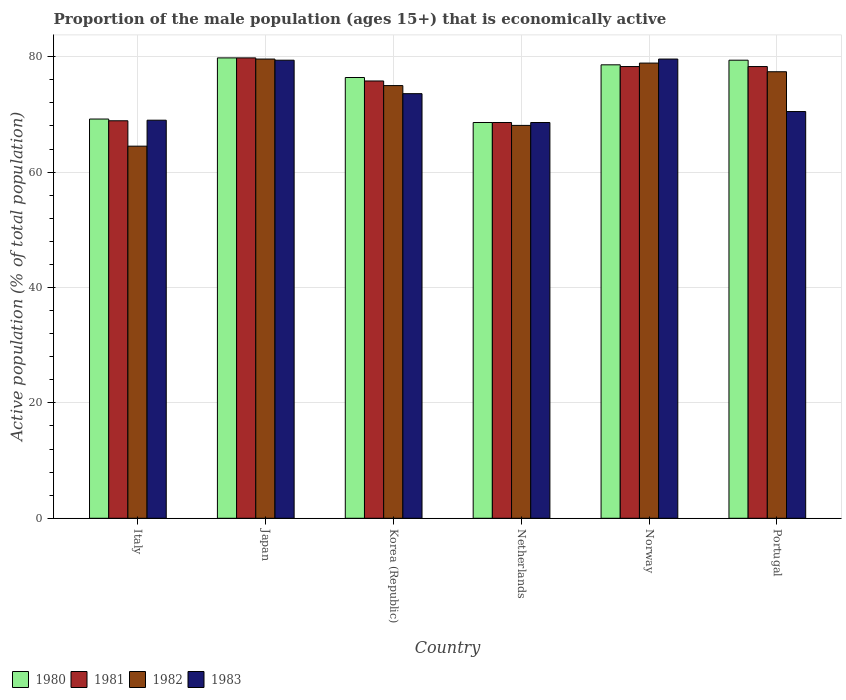How many different coloured bars are there?
Provide a succinct answer. 4. Are the number of bars per tick equal to the number of legend labels?
Keep it short and to the point. Yes. How many bars are there on the 4th tick from the right?
Offer a terse response. 4. What is the proportion of the male population that is economically active in 1982 in Korea (Republic)?
Give a very brief answer. 75. Across all countries, what is the maximum proportion of the male population that is economically active in 1982?
Make the answer very short. 79.6. Across all countries, what is the minimum proportion of the male population that is economically active in 1983?
Your answer should be compact. 68.6. In which country was the proportion of the male population that is economically active in 1981 minimum?
Ensure brevity in your answer.  Netherlands. What is the total proportion of the male population that is economically active in 1980 in the graph?
Your answer should be compact. 452. What is the difference between the proportion of the male population that is economically active in 1982 in Japan and that in Korea (Republic)?
Your answer should be compact. 4.6. What is the average proportion of the male population that is economically active in 1982 per country?
Give a very brief answer. 73.92. What is the ratio of the proportion of the male population that is economically active in 1980 in Japan to that in Norway?
Keep it short and to the point. 1.02. Is the proportion of the male population that is economically active in 1981 in Japan less than that in Korea (Republic)?
Your answer should be very brief. No. Is the difference between the proportion of the male population that is economically active in 1982 in Italy and Netherlands greater than the difference between the proportion of the male population that is economically active in 1980 in Italy and Netherlands?
Your answer should be very brief. No. What is the difference between the highest and the second highest proportion of the male population that is economically active in 1983?
Provide a succinct answer. -5.8. What is the difference between the highest and the lowest proportion of the male population that is economically active in 1981?
Offer a very short reply. 11.2. In how many countries, is the proportion of the male population that is economically active in 1983 greater than the average proportion of the male population that is economically active in 1983 taken over all countries?
Your answer should be very brief. 3. Is it the case that in every country, the sum of the proportion of the male population that is economically active in 1981 and proportion of the male population that is economically active in 1983 is greater than the sum of proportion of the male population that is economically active in 1982 and proportion of the male population that is economically active in 1980?
Provide a short and direct response. No. What does the 3rd bar from the left in Japan represents?
Ensure brevity in your answer.  1982. Is it the case that in every country, the sum of the proportion of the male population that is economically active in 1983 and proportion of the male population that is economically active in 1980 is greater than the proportion of the male population that is economically active in 1982?
Offer a very short reply. Yes. How many bars are there?
Offer a very short reply. 24. How many countries are there in the graph?
Provide a short and direct response. 6. What is the difference between two consecutive major ticks on the Y-axis?
Provide a succinct answer. 20. Where does the legend appear in the graph?
Provide a succinct answer. Bottom left. What is the title of the graph?
Offer a terse response. Proportion of the male population (ages 15+) that is economically active. What is the label or title of the Y-axis?
Provide a succinct answer. Active population (% of total population). What is the Active population (% of total population) of 1980 in Italy?
Give a very brief answer. 69.2. What is the Active population (% of total population) of 1981 in Italy?
Give a very brief answer. 68.9. What is the Active population (% of total population) of 1982 in Italy?
Provide a short and direct response. 64.5. What is the Active population (% of total population) of 1980 in Japan?
Make the answer very short. 79.8. What is the Active population (% of total population) in 1981 in Japan?
Offer a very short reply. 79.8. What is the Active population (% of total population) of 1982 in Japan?
Offer a very short reply. 79.6. What is the Active population (% of total population) in 1983 in Japan?
Offer a very short reply. 79.4. What is the Active population (% of total population) in 1980 in Korea (Republic)?
Give a very brief answer. 76.4. What is the Active population (% of total population) of 1981 in Korea (Republic)?
Offer a terse response. 75.8. What is the Active population (% of total population) in 1982 in Korea (Republic)?
Offer a very short reply. 75. What is the Active population (% of total population) in 1983 in Korea (Republic)?
Offer a terse response. 73.6. What is the Active population (% of total population) in 1980 in Netherlands?
Offer a very short reply. 68.6. What is the Active population (% of total population) of 1981 in Netherlands?
Your answer should be very brief. 68.6. What is the Active population (% of total population) in 1982 in Netherlands?
Provide a short and direct response. 68.1. What is the Active population (% of total population) in 1983 in Netherlands?
Your answer should be compact. 68.6. What is the Active population (% of total population) in 1980 in Norway?
Your answer should be very brief. 78.6. What is the Active population (% of total population) in 1981 in Norway?
Offer a very short reply. 78.3. What is the Active population (% of total population) of 1982 in Norway?
Your answer should be compact. 78.9. What is the Active population (% of total population) in 1983 in Norway?
Offer a very short reply. 79.6. What is the Active population (% of total population) in 1980 in Portugal?
Offer a terse response. 79.4. What is the Active population (% of total population) of 1981 in Portugal?
Provide a short and direct response. 78.3. What is the Active population (% of total population) of 1982 in Portugal?
Offer a very short reply. 77.4. What is the Active population (% of total population) of 1983 in Portugal?
Keep it short and to the point. 70.5. Across all countries, what is the maximum Active population (% of total population) in 1980?
Ensure brevity in your answer.  79.8. Across all countries, what is the maximum Active population (% of total population) of 1981?
Make the answer very short. 79.8. Across all countries, what is the maximum Active population (% of total population) of 1982?
Offer a terse response. 79.6. Across all countries, what is the maximum Active population (% of total population) of 1983?
Keep it short and to the point. 79.6. Across all countries, what is the minimum Active population (% of total population) of 1980?
Give a very brief answer. 68.6. Across all countries, what is the minimum Active population (% of total population) in 1981?
Your answer should be very brief. 68.6. Across all countries, what is the minimum Active population (% of total population) in 1982?
Offer a terse response. 64.5. Across all countries, what is the minimum Active population (% of total population) of 1983?
Your answer should be compact. 68.6. What is the total Active population (% of total population) in 1980 in the graph?
Your answer should be compact. 452. What is the total Active population (% of total population) of 1981 in the graph?
Your answer should be very brief. 449.7. What is the total Active population (% of total population) in 1982 in the graph?
Provide a succinct answer. 443.5. What is the total Active population (% of total population) of 1983 in the graph?
Give a very brief answer. 440.7. What is the difference between the Active population (% of total population) in 1980 in Italy and that in Japan?
Give a very brief answer. -10.6. What is the difference between the Active population (% of total population) in 1982 in Italy and that in Japan?
Offer a very short reply. -15.1. What is the difference between the Active population (% of total population) of 1980 in Italy and that in Korea (Republic)?
Your response must be concise. -7.2. What is the difference between the Active population (% of total population) in 1982 in Italy and that in Korea (Republic)?
Provide a succinct answer. -10.5. What is the difference between the Active population (% of total population) of 1982 in Italy and that in Netherlands?
Your answer should be compact. -3.6. What is the difference between the Active population (% of total population) of 1983 in Italy and that in Netherlands?
Offer a very short reply. 0.4. What is the difference between the Active population (% of total population) of 1981 in Italy and that in Norway?
Offer a very short reply. -9.4. What is the difference between the Active population (% of total population) in 1982 in Italy and that in Norway?
Keep it short and to the point. -14.4. What is the difference between the Active population (% of total population) in 1980 in Italy and that in Portugal?
Offer a very short reply. -10.2. What is the difference between the Active population (% of total population) in 1981 in Italy and that in Portugal?
Offer a very short reply. -9.4. What is the difference between the Active population (% of total population) of 1980 in Japan and that in Korea (Republic)?
Ensure brevity in your answer.  3.4. What is the difference between the Active population (% of total population) of 1983 in Japan and that in Korea (Republic)?
Your answer should be compact. 5.8. What is the difference between the Active population (% of total population) of 1982 in Japan and that in Netherlands?
Ensure brevity in your answer.  11.5. What is the difference between the Active population (% of total population) in 1980 in Japan and that in Norway?
Give a very brief answer. 1.2. What is the difference between the Active population (% of total population) in 1982 in Japan and that in Norway?
Your answer should be compact. 0.7. What is the difference between the Active population (% of total population) in 1981 in Japan and that in Portugal?
Offer a terse response. 1.5. What is the difference between the Active population (% of total population) of 1982 in Japan and that in Portugal?
Provide a short and direct response. 2.2. What is the difference between the Active population (% of total population) in 1980 in Korea (Republic) and that in Netherlands?
Offer a terse response. 7.8. What is the difference between the Active population (% of total population) in 1982 in Korea (Republic) and that in Netherlands?
Provide a short and direct response. 6.9. What is the difference between the Active population (% of total population) of 1983 in Korea (Republic) and that in Netherlands?
Your response must be concise. 5. What is the difference between the Active population (% of total population) of 1982 in Korea (Republic) and that in Norway?
Offer a very short reply. -3.9. What is the difference between the Active population (% of total population) of 1983 in Korea (Republic) and that in Norway?
Offer a very short reply. -6. What is the difference between the Active population (% of total population) in 1980 in Korea (Republic) and that in Portugal?
Your answer should be very brief. -3. What is the difference between the Active population (% of total population) of 1983 in Korea (Republic) and that in Portugal?
Offer a terse response. 3.1. What is the difference between the Active population (% of total population) of 1980 in Netherlands and that in Norway?
Offer a very short reply. -10. What is the difference between the Active population (% of total population) of 1981 in Netherlands and that in Norway?
Ensure brevity in your answer.  -9.7. What is the difference between the Active population (% of total population) in 1982 in Netherlands and that in Norway?
Give a very brief answer. -10.8. What is the difference between the Active population (% of total population) of 1983 in Netherlands and that in Norway?
Ensure brevity in your answer.  -11. What is the difference between the Active population (% of total population) of 1982 in Netherlands and that in Portugal?
Provide a succinct answer. -9.3. What is the difference between the Active population (% of total population) of 1983 in Netherlands and that in Portugal?
Make the answer very short. -1.9. What is the difference between the Active population (% of total population) in 1983 in Norway and that in Portugal?
Provide a short and direct response. 9.1. What is the difference between the Active population (% of total population) of 1980 in Italy and the Active population (% of total population) of 1981 in Japan?
Offer a terse response. -10.6. What is the difference between the Active population (% of total population) in 1982 in Italy and the Active population (% of total population) in 1983 in Japan?
Your answer should be very brief. -14.9. What is the difference between the Active population (% of total population) in 1980 in Italy and the Active population (% of total population) in 1981 in Netherlands?
Your answer should be compact. 0.6. What is the difference between the Active population (% of total population) of 1981 in Italy and the Active population (% of total population) of 1983 in Netherlands?
Keep it short and to the point. 0.3. What is the difference between the Active population (% of total population) in 1980 in Italy and the Active population (% of total population) in 1981 in Norway?
Give a very brief answer. -9.1. What is the difference between the Active population (% of total population) in 1980 in Italy and the Active population (% of total population) in 1982 in Norway?
Ensure brevity in your answer.  -9.7. What is the difference between the Active population (% of total population) of 1981 in Italy and the Active population (% of total population) of 1982 in Norway?
Your answer should be compact. -10. What is the difference between the Active population (% of total population) in 1981 in Italy and the Active population (% of total population) in 1983 in Norway?
Your answer should be very brief. -10.7. What is the difference between the Active population (% of total population) in 1982 in Italy and the Active population (% of total population) in 1983 in Norway?
Provide a succinct answer. -15.1. What is the difference between the Active population (% of total population) of 1980 in Italy and the Active population (% of total population) of 1981 in Portugal?
Provide a succinct answer. -9.1. What is the difference between the Active population (% of total population) of 1981 in Italy and the Active population (% of total population) of 1982 in Portugal?
Offer a very short reply. -8.5. What is the difference between the Active population (% of total population) of 1981 in Italy and the Active population (% of total population) of 1983 in Portugal?
Keep it short and to the point. -1.6. What is the difference between the Active population (% of total population) in 1982 in Italy and the Active population (% of total population) in 1983 in Portugal?
Keep it short and to the point. -6. What is the difference between the Active population (% of total population) of 1980 in Japan and the Active population (% of total population) of 1981 in Korea (Republic)?
Offer a very short reply. 4. What is the difference between the Active population (% of total population) in 1981 in Japan and the Active population (% of total population) in 1982 in Korea (Republic)?
Offer a very short reply. 4.8. What is the difference between the Active population (% of total population) in 1981 in Japan and the Active population (% of total population) in 1983 in Korea (Republic)?
Ensure brevity in your answer.  6.2. What is the difference between the Active population (% of total population) of 1982 in Japan and the Active population (% of total population) of 1983 in Korea (Republic)?
Provide a succinct answer. 6. What is the difference between the Active population (% of total population) of 1980 in Japan and the Active population (% of total population) of 1983 in Netherlands?
Your response must be concise. 11.2. What is the difference between the Active population (% of total population) in 1981 in Japan and the Active population (% of total population) in 1983 in Netherlands?
Your answer should be compact. 11.2. What is the difference between the Active population (% of total population) of 1980 in Japan and the Active population (% of total population) of 1981 in Norway?
Keep it short and to the point. 1.5. What is the difference between the Active population (% of total population) of 1980 in Japan and the Active population (% of total population) of 1982 in Norway?
Your response must be concise. 0.9. What is the difference between the Active population (% of total population) of 1981 in Japan and the Active population (% of total population) of 1982 in Norway?
Your response must be concise. 0.9. What is the difference between the Active population (% of total population) of 1981 in Japan and the Active population (% of total population) of 1983 in Norway?
Offer a very short reply. 0.2. What is the difference between the Active population (% of total population) in 1982 in Japan and the Active population (% of total population) in 1983 in Norway?
Make the answer very short. 0. What is the difference between the Active population (% of total population) of 1980 in Japan and the Active population (% of total population) of 1982 in Portugal?
Give a very brief answer. 2.4. What is the difference between the Active population (% of total population) of 1980 in Japan and the Active population (% of total population) of 1983 in Portugal?
Keep it short and to the point. 9.3. What is the difference between the Active population (% of total population) in 1981 in Japan and the Active population (% of total population) in 1982 in Portugal?
Ensure brevity in your answer.  2.4. What is the difference between the Active population (% of total population) of 1982 in Japan and the Active population (% of total population) of 1983 in Portugal?
Ensure brevity in your answer.  9.1. What is the difference between the Active population (% of total population) in 1980 in Korea (Republic) and the Active population (% of total population) in 1981 in Netherlands?
Make the answer very short. 7.8. What is the difference between the Active population (% of total population) in 1980 in Korea (Republic) and the Active population (% of total population) in 1982 in Netherlands?
Make the answer very short. 8.3. What is the difference between the Active population (% of total population) of 1981 in Korea (Republic) and the Active population (% of total population) of 1983 in Netherlands?
Make the answer very short. 7.2. What is the difference between the Active population (% of total population) in 1982 in Korea (Republic) and the Active population (% of total population) in 1983 in Netherlands?
Keep it short and to the point. 6.4. What is the difference between the Active population (% of total population) in 1980 in Korea (Republic) and the Active population (% of total population) in 1981 in Norway?
Ensure brevity in your answer.  -1.9. What is the difference between the Active population (% of total population) of 1980 in Korea (Republic) and the Active population (% of total population) of 1982 in Norway?
Ensure brevity in your answer.  -2.5. What is the difference between the Active population (% of total population) of 1980 in Korea (Republic) and the Active population (% of total population) of 1983 in Norway?
Offer a very short reply. -3.2. What is the difference between the Active population (% of total population) of 1981 in Korea (Republic) and the Active population (% of total population) of 1983 in Norway?
Ensure brevity in your answer.  -3.8. What is the difference between the Active population (% of total population) of 1980 in Netherlands and the Active population (% of total population) of 1983 in Norway?
Provide a short and direct response. -11. What is the difference between the Active population (% of total population) of 1981 in Netherlands and the Active population (% of total population) of 1983 in Norway?
Your answer should be compact. -11. What is the difference between the Active population (% of total population) of 1981 in Netherlands and the Active population (% of total population) of 1982 in Portugal?
Your answer should be compact. -8.8. What is the difference between the Active population (% of total population) in 1981 in Netherlands and the Active population (% of total population) in 1983 in Portugal?
Provide a succinct answer. -1.9. What is the difference between the Active population (% of total population) in 1982 in Netherlands and the Active population (% of total population) in 1983 in Portugal?
Keep it short and to the point. -2.4. What is the difference between the Active population (% of total population) of 1980 in Norway and the Active population (% of total population) of 1983 in Portugal?
Your response must be concise. 8.1. What is the average Active population (% of total population) in 1980 per country?
Keep it short and to the point. 75.33. What is the average Active population (% of total population) of 1981 per country?
Keep it short and to the point. 74.95. What is the average Active population (% of total population) of 1982 per country?
Make the answer very short. 73.92. What is the average Active population (% of total population) in 1983 per country?
Your response must be concise. 73.45. What is the difference between the Active population (% of total population) in 1981 and Active population (% of total population) in 1983 in Italy?
Your answer should be very brief. -0.1. What is the difference between the Active population (% of total population) of 1982 and Active population (% of total population) of 1983 in Italy?
Ensure brevity in your answer.  -4.5. What is the difference between the Active population (% of total population) of 1980 and Active population (% of total population) of 1982 in Japan?
Ensure brevity in your answer.  0.2. What is the difference between the Active population (% of total population) of 1980 and Active population (% of total population) of 1983 in Japan?
Keep it short and to the point. 0.4. What is the difference between the Active population (% of total population) of 1981 and Active population (% of total population) of 1983 in Japan?
Keep it short and to the point. 0.4. What is the difference between the Active population (% of total population) in 1980 and Active population (% of total population) in 1981 in Korea (Republic)?
Offer a very short reply. 0.6. What is the difference between the Active population (% of total population) in 1980 and Active population (% of total population) in 1982 in Korea (Republic)?
Your answer should be compact. 1.4. What is the difference between the Active population (% of total population) of 1981 and Active population (% of total population) of 1982 in Korea (Republic)?
Your answer should be very brief. 0.8. What is the difference between the Active population (% of total population) in 1981 and Active population (% of total population) in 1983 in Korea (Republic)?
Keep it short and to the point. 2.2. What is the difference between the Active population (% of total population) in 1980 and Active population (% of total population) in 1981 in Netherlands?
Make the answer very short. 0. What is the difference between the Active population (% of total population) in 1980 and Active population (% of total population) in 1983 in Netherlands?
Provide a short and direct response. 0. What is the difference between the Active population (% of total population) in 1981 and Active population (% of total population) in 1982 in Netherlands?
Provide a short and direct response. 0.5. What is the difference between the Active population (% of total population) in 1981 and Active population (% of total population) in 1983 in Netherlands?
Your answer should be compact. 0. What is the difference between the Active population (% of total population) in 1980 and Active population (% of total population) in 1982 in Norway?
Offer a very short reply. -0.3. What is the difference between the Active population (% of total population) of 1982 and Active population (% of total population) of 1983 in Norway?
Make the answer very short. -0.7. What is the difference between the Active population (% of total population) of 1980 and Active population (% of total population) of 1981 in Portugal?
Give a very brief answer. 1.1. What is the difference between the Active population (% of total population) of 1980 and Active population (% of total population) of 1983 in Portugal?
Make the answer very short. 8.9. What is the difference between the Active population (% of total population) in 1981 and Active population (% of total population) in 1982 in Portugal?
Provide a short and direct response. 0.9. What is the difference between the Active population (% of total population) of 1981 and Active population (% of total population) of 1983 in Portugal?
Your response must be concise. 7.8. What is the ratio of the Active population (% of total population) in 1980 in Italy to that in Japan?
Give a very brief answer. 0.87. What is the ratio of the Active population (% of total population) in 1981 in Italy to that in Japan?
Your answer should be compact. 0.86. What is the ratio of the Active population (% of total population) in 1982 in Italy to that in Japan?
Your response must be concise. 0.81. What is the ratio of the Active population (% of total population) in 1983 in Italy to that in Japan?
Provide a succinct answer. 0.87. What is the ratio of the Active population (% of total population) of 1980 in Italy to that in Korea (Republic)?
Give a very brief answer. 0.91. What is the ratio of the Active population (% of total population) of 1981 in Italy to that in Korea (Republic)?
Make the answer very short. 0.91. What is the ratio of the Active population (% of total population) in 1982 in Italy to that in Korea (Republic)?
Your response must be concise. 0.86. What is the ratio of the Active population (% of total population) in 1983 in Italy to that in Korea (Republic)?
Make the answer very short. 0.94. What is the ratio of the Active population (% of total population) of 1980 in Italy to that in Netherlands?
Keep it short and to the point. 1.01. What is the ratio of the Active population (% of total population) of 1981 in Italy to that in Netherlands?
Offer a very short reply. 1. What is the ratio of the Active population (% of total population) of 1982 in Italy to that in Netherlands?
Provide a succinct answer. 0.95. What is the ratio of the Active population (% of total population) in 1983 in Italy to that in Netherlands?
Make the answer very short. 1.01. What is the ratio of the Active population (% of total population) of 1980 in Italy to that in Norway?
Make the answer very short. 0.88. What is the ratio of the Active population (% of total population) of 1981 in Italy to that in Norway?
Your answer should be compact. 0.88. What is the ratio of the Active population (% of total population) in 1982 in Italy to that in Norway?
Your answer should be very brief. 0.82. What is the ratio of the Active population (% of total population) of 1983 in Italy to that in Norway?
Your response must be concise. 0.87. What is the ratio of the Active population (% of total population) in 1980 in Italy to that in Portugal?
Ensure brevity in your answer.  0.87. What is the ratio of the Active population (% of total population) of 1981 in Italy to that in Portugal?
Provide a succinct answer. 0.88. What is the ratio of the Active population (% of total population) in 1983 in Italy to that in Portugal?
Provide a succinct answer. 0.98. What is the ratio of the Active population (% of total population) in 1980 in Japan to that in Korea (Republic)?
Your answer should be very brief. 1.04. What is the ratio of the Active population (% of total population) of 1981 in Japan to that in Korea (Republic)?
Your answer should be very brief. 1.05. What is the ratio of the Active population (% of total population) of 1982 in Japan to that in Korea (Republic)?
Your answer should be very brief. 1.06. What is the ratio of the Active population (% of total population) of 1983 in Japan to that in Korea (Republic)?
Offer a terse response. 1.08. What is the ratio of the Active population (% of total population) of 1980 in Japan to that in Netherlands?
Ensure brevity in your answer.  1.16. What is the ratio of the Active population (% of total population) in 1981 in Japan to that in Netherlands?
Give a very brief answer. 1.16. What is the ratio of the Active population (% of total population) in 1982 in Japan to that in Netherlands?
Keep it short and to the point. 1.17. What is the ratio of the Active population (% of total population) of 1983 in Japan to that in Netherlands?
Your answer should be very brief. 1.16. What is the ratio of the Active population (% of total population) of 1980 in Japan to that in Norway?
Keep it short and to the point. 1.02. What is the ratio of the Active population (% of total population) of 1981 in Japan to that in Norway?
Offer a very short reply. 1.02. What is the ratio of the Active population (% of total population) in 1982 in Japan to that in Norway?
Your response must be concise. 1.01. What is the ratio of the Active population (% of total population) of 1980 in Japan to that in Portugal?
Provide a short and direct response. 1. What is the ratio of the Active population (% of total population) in 1981 in Japan to that in Portugal?
Your response must be concise. 1.02. What is the ratio of the Active population (% of total population) of 1982 in Japan to that in Portugal?
Provide a short and direct response. 1.03. What is the ratio of the Active population (% of total population) in 1983 in Japan to that in Portugal?
Offer a very short reply. 1.13. What is the ratio of the Active population (% of total population) of 1980 in Korea (Republic) to that in Netherlands?
Provide a short and direct response. 1.11. What is the ratio of the Active population (% of total population) in 1981 in Korea (Republic) to that in Netherlands?
Ensure brevity in your answer.  1.1. What is the ratio of the Active population (% of total population) of 1982 in Korea (Republic) to that in Netherlands?
Make the answer very short. 1.1. What is the ratio of the Active population (% of total population) in 1983 in Korea (Republic) to that in Netherlands?
Make the answer very short. 1.07. What is the ratio of the Active population (% of total population) of 1981 in Korea (Republic) to that in Norway?
Your response must be concise. 0.97. What is the ratio of the Active population (% of total population) of 1982 in Korea (Republic) to that in Norway?
Your answer should be compact. 0.95. What is the ratio of the Active population (% of total population) in 1983 in Korea (Republic) to that in Norway?
Provide a short and direct response. 0.92. What is the ratio of the Active population (% of total population) of 1980 in Korea (Republic) to that in Portugal?
Give a very brief answer. 0.96. What is the ratio of the Active population (% of total population) in 1981 in Korea (Republic) to that in Portugal?
Make the answer very short. 0.97. What is the ratio of the Active population (% of total population) in 1982 in Korea (Republic) to that in Portugal?
Offer a terse response. 0.97. What is the ratio of the Active population (% of total population) in 1983 in Korea (Republic) to that in Portugal?
Provide a short and direct response. 1.04. What is the ratio of the Active population (% of total population) of 1980 in Netherlands to that in Norway?
Your answer should be very brief. 0.87. What is the ratio of the Active population (% of total population) of 1981 in Netherlands to that in Norway?
Your answer should be very brief. 0.88. What is the ratio of the Active population (% of total population) of 1982 in Netherlands to that in Norway?
Provide a short and direct response. 0.86. What is the ratio of the Active population (% of total population) in 1983 in Netherlands to that in Norway?
Make the answer very short. 0.86. What is the ratio of the Active population (% of total population) in 1980 in Netherlands to that in Portugal?
Offer a very short reply. 0.86. What is the ratio of the Active population (% of total population) of 1981 in Netherlands to that in Portugal?
Provide a short and direct response. 0.88. What is the ratio of the Active population (% of total population) of 1982 in Netherlands to that in Portugal?
Provide a succinct answer. 0.88. What is the ratio of the Active population (% of total population) in 1983 in Netherlands to that in Portugal?
Your answer should be compact. 0.97. What is the ratio of the Active population (% of total population) in 1981 in Norway to that in Portugal?
Offer a very short reply. 1. What is the ratio of the Active population (% of total population) in 1982 in Norway to that in Portugal?
Your answer should be very brief. 1.02. What is the ratio of the Active population (% of total population) of 1983 in Norway to that in Portugal?
Offer a very short reply. 1.13. What is the difference between the highest and the second highest Active population (% of total population) of 1982?
Your answer should be compact. 0.7. What is the difference between the highest and the lowest Active population (% of total population) of 1983?
Offer a terse response. 11. 